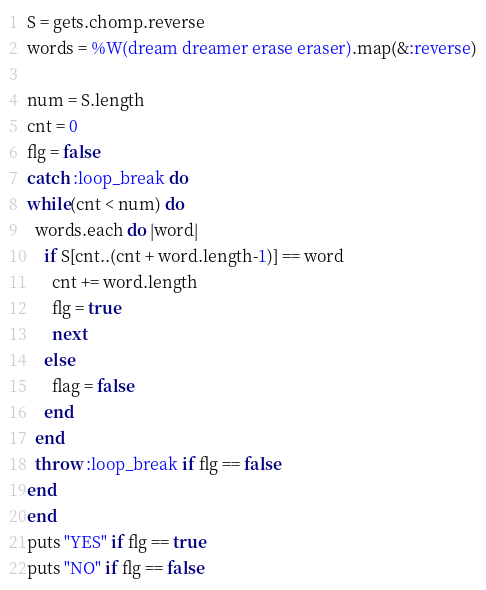Convert code to text. <code><loc_0><loc_0><loc_500><loc_500><_Ruby_>S = gets.chomp.reverse
words = %W(dream dreamer erase eraser).map(&:reverse)

num = S.length
cnt = 0
flg = false
catch :loop_break do
while(cnt < num) do
  words.each do |word|
    if S[cnt..(cnt + word.length-1)] == word
      cnt += word.length
      flg = true
      next
    else
      flag = false
    end
  end
  throw :loop_break if flg == false
end
end
puts "YES" if flg == true
puts "NO" if flg == false</code> 